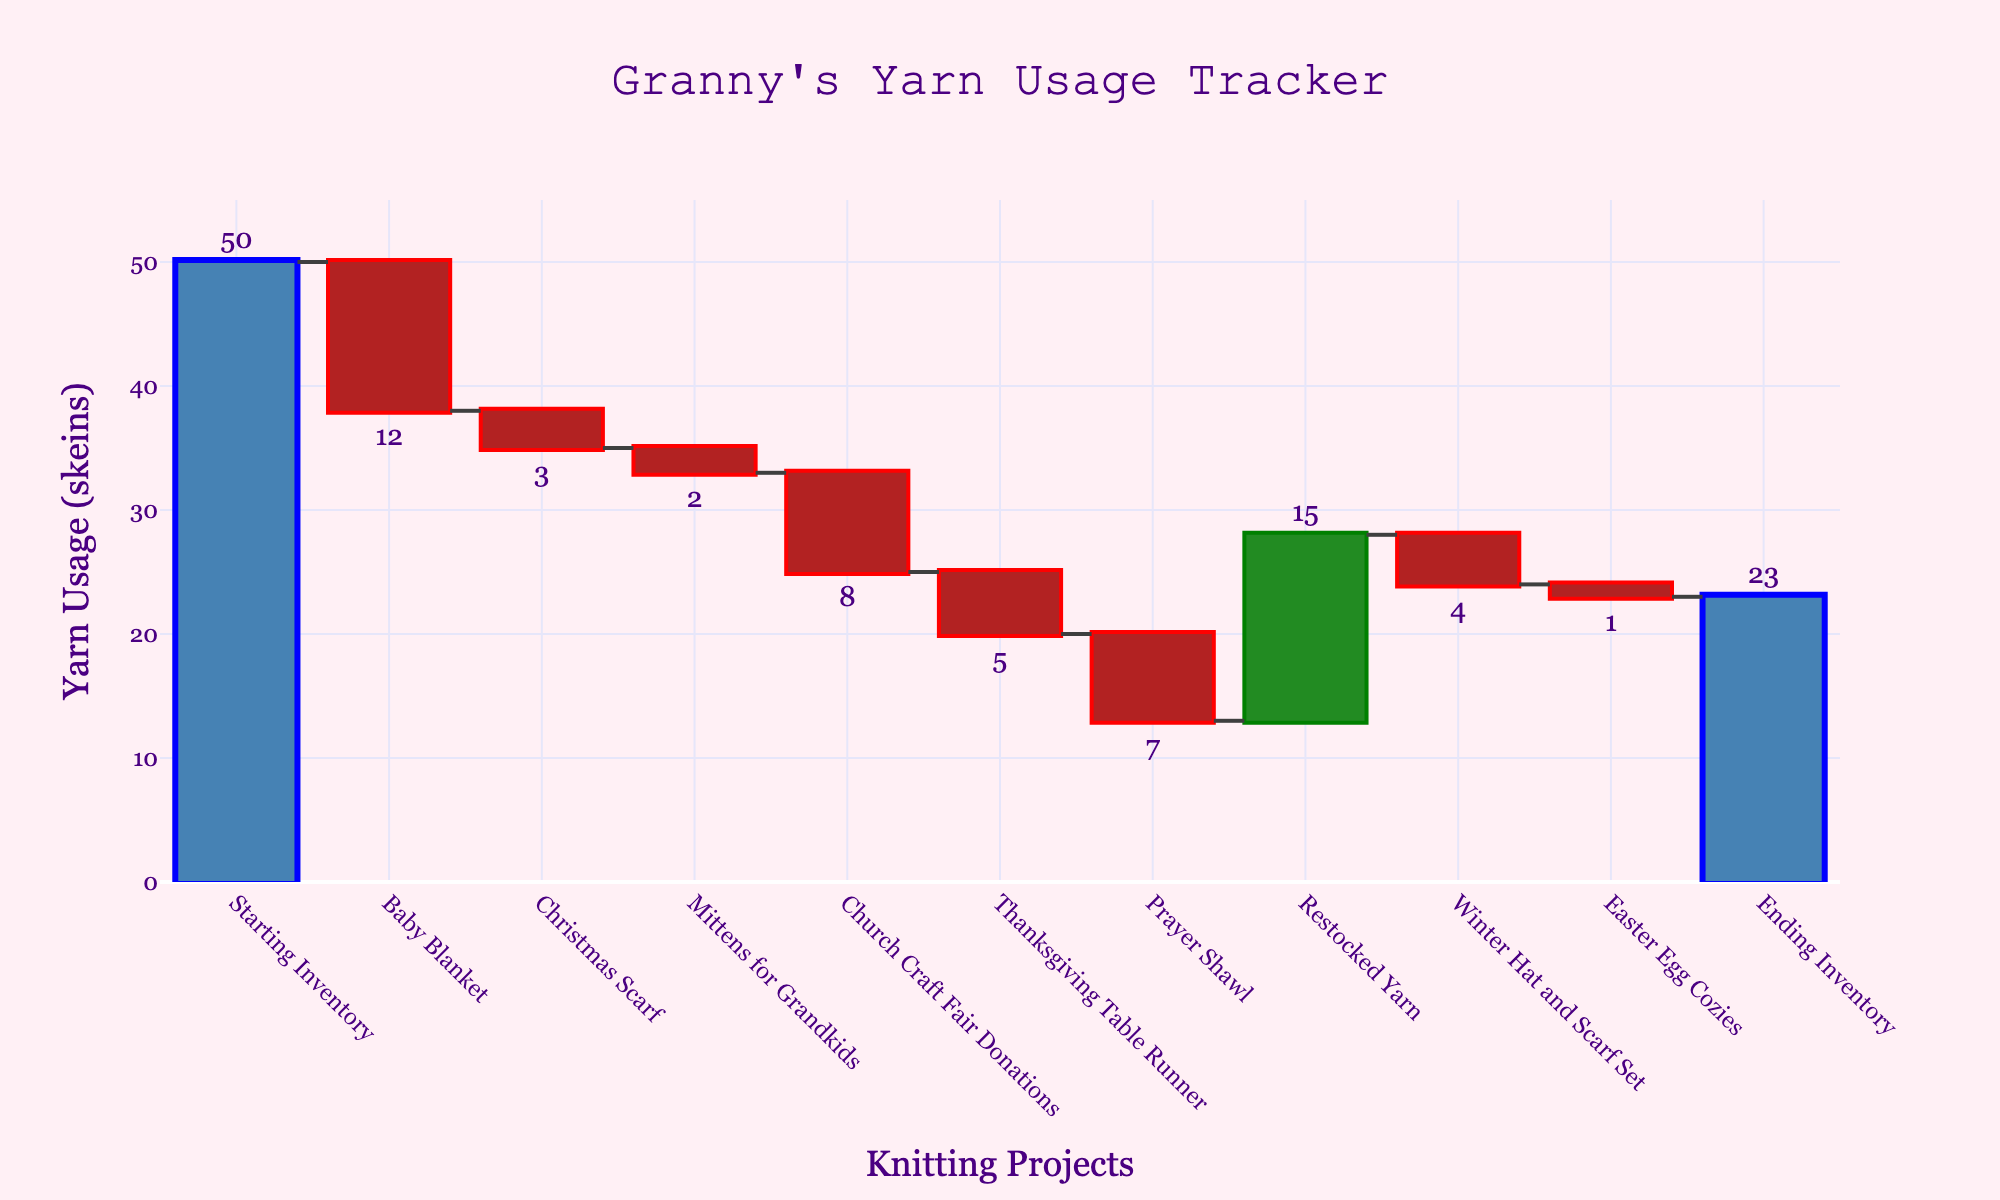How many knitting projects are tracked in the chart? By counting each data point from "Baby Blanket" to "Easter Egg Cozies" and excluding the starting and ending inventory, you get the total number of projects. That's 9 projects.
Answer: 9 What is the title of the chart? The title is displayed prominently at the top of the chart and reads "Granny's Yarn Usage Tracker".
Answer: Granny's Yarn Usage Tracker Which project used the most yarn? By comparing the yarn usage values represented as bars, "Baby Blanket" has the highest negative value of -12 skeins.
Answer: Baby Blanket How many skeins of yarn were added back from restocking? Look for the project labeled "Restocked Yarn" and check its corresponding bar value, which is 15 skeins.
Answer: 15 What is the ending inventory of yarn? The ending value is shown as the last data point on the chart labeled "Ending Inventory," which is 23 skeins.
Answer: 23 What would the total yarn usage be if the restocked yarn had not been added? To find this, sum the yarn usage without "Restocked Yarn": (-12) + (-3) + (-2) + (-8) + (-5) + (-7) + (-4) + (-1) = -42 skeins. The starting inventory was 50 skeins, so without restocking, it would be 50 - 42 = 8 skeins at the end.
Answer: 8 Which project used the least amount of yarn? Compare each project's yarn usage and identify the one with the smallest absolute value, which is "Easter Egg Cozies" at -1 skein.
Answer: Easter Egg Cozies By how many skeins did the "Christmas Scarf" project decrease the yarn inventory? Locate "Christmas Scarf" and check its corresponding bar value, which is -3 skeins.
Answer: 3 